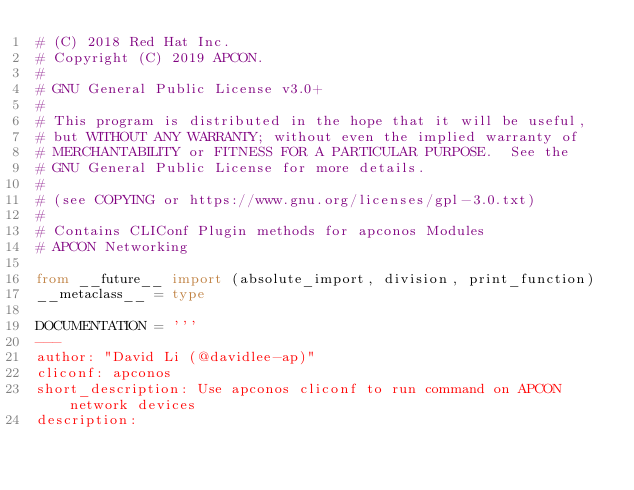<code> <loc_0><loc_0><loc_500><loc_500><_Python_># (C) 2018 Red Hat Inc.
# Copyright (C) 2019 APCON.
#
# GNU General Public License v3.0+
#
# This program is distributed in the hope that it will be useful,
# but WITHOUT ANY WARRANTY; without even the implied warranty of
# MERCHANTABILITY or FITNESS FOR A PARTICULAR PURPOSE.  See the
# GNU General Public License for more details.
#
# (see COPYING or https://www.gnu.org/licenses/gpl-3.0.txt)
#
# Contains CLIConf Plugin methods for apconos Modules
# APCON Networking

from __future__ import (absolute_import, division, print_function)
__metaclass__ = type

DOCUMENTATION = '''
---
author: "David Li (@davidlee-ap)"
cliconf: apconos
short_description: Use apconos cliconf to run command on APCON network devices
description:</code> 